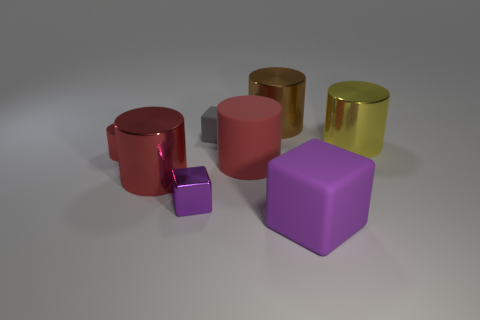There is a red metal object that is the same size as the brown object; what shape is it?
Your answer should be very brief. Cylinder. Are there any other things that are the same size as the gray matte block?
Provide a succinct answer. Yes. There is a small block that is in front of the red cylinder that is in front of the big matte cylinder; what is its material?
Give a very brief answer. Metal. Does the red matte thing have the same size as the brown shiny cylinder?
Ensure brevity in your answer.  Yes. What number of things are large objects in front of the large yellow metal thing or cyan rubber balls?
Provide a short and direct response. 3. There is a matte thing on the right side of the shiny thing behind the yellow shiny cylinder; what shape is it?
Keep it short and to the point. Cube. Is the size of the gray block the same as the purple object that is right of the purple shiny block?
Make the answer very short. No. What is the purple cube to the right of the tiny gray rubber object made of?
Provide a short and direct response. Rubber. How many things are behind the large cube and in front of the big brown shiny thing?
Keep it short and to the point. 6. There is a cube that is the same size as the yellow shiny thing; what is its material?
Provide a short and direct response. Rubber. 